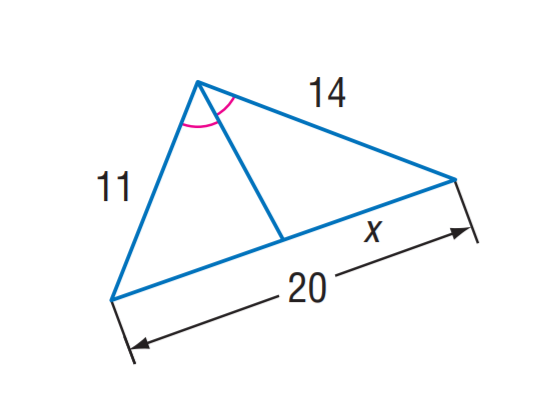Answer the mathemtical geometry problem and directly provide the correct option letter.
Question: Find x.
Choices: A: 11 B: 11.2 C: 12.4 D: 13.8 B 